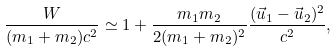Convert formula to latex. <formula><loc_0><loc_0><loc_500><loc_500>\frac { W } { ( m _ { 1 } + m _ { 2 } ) c ^ { 2 } } \simeq 1 + \frac { m _ { 1 } m _ { 2 } } { 2 ( m _ { 1 } + m _ { 2 } ) ^ { 2 } } \frac { ( \vec { u } _ { 1 } - \vec { u } _ { 2 } ) ^ { 2 } } { c ^ { 2 } } ,</formula> 